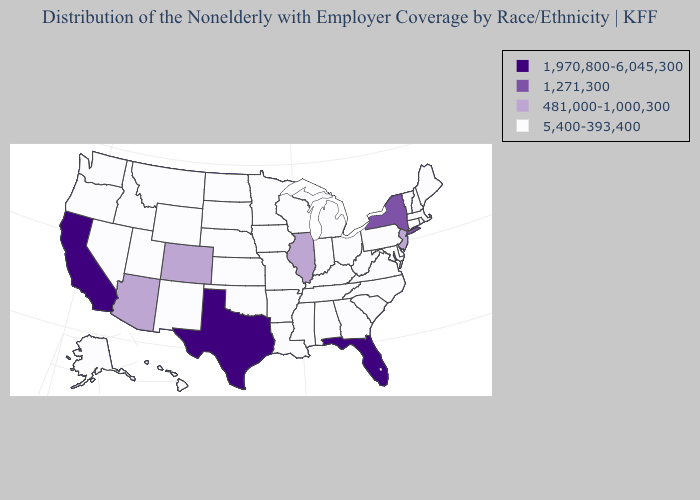What is the value of New Mexico?
Be succinct. 5,400-393,400. Does the map have missing data?
Write a very short answer. No. Does Kansas have a lower value than Arkansas?
Short answer required. No. What is the value of Arkansas?
Short answer required. 5,400-393,400. Name the states that have a value in the range 481,000-1,000,300?
Answer briefly. Arizona, Colorado, Illinois, New Jersey. Name the states that have a value in the range 1,970,800-6,045,300?
Quick response, please. California, Florida, Texas. Among the states that border California , which have the lowest value?
Write a very short answer. Nevada, Oregon. Which states have the highest value in the USA?
Answer briefly. California, Florida, Texas. What is the value of Michigan?
Give a very brief answer. 5,400-393,400. How many symbols are there in the legend?
Keep it brief. 4. Name the states that have a value in the range 481,000-1,000,300?
Write a very short answer. Arizona, Colorado, Illinois, New Jersey. What is the highest value in states that border West Virginia?
Quick response, please. 5,400-393,400. Is the legend a continuous bar?
Quick response, please. No. Name the states that have a value in the range 1,970,800-6,045,300?
Answer briefly. California, Florida, Texas. 